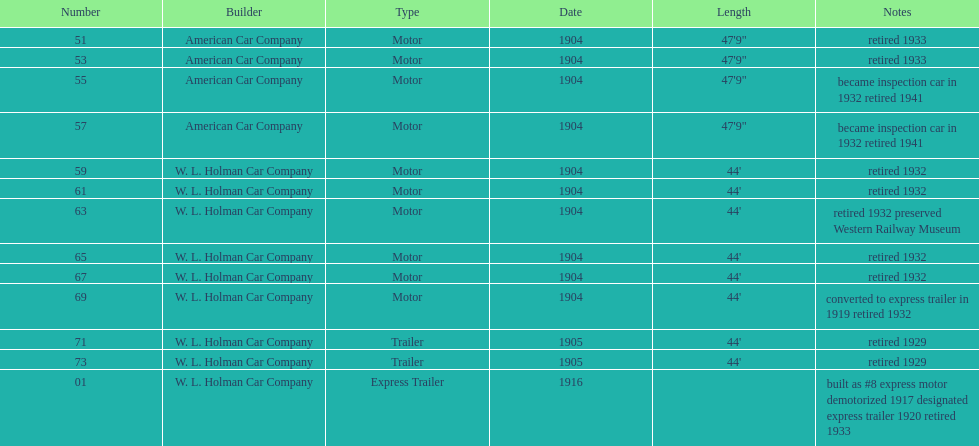Did either the american car company or w.l. holman car company manufacture vehicles that were 44 feet long? W. L. Holman Car Company. 